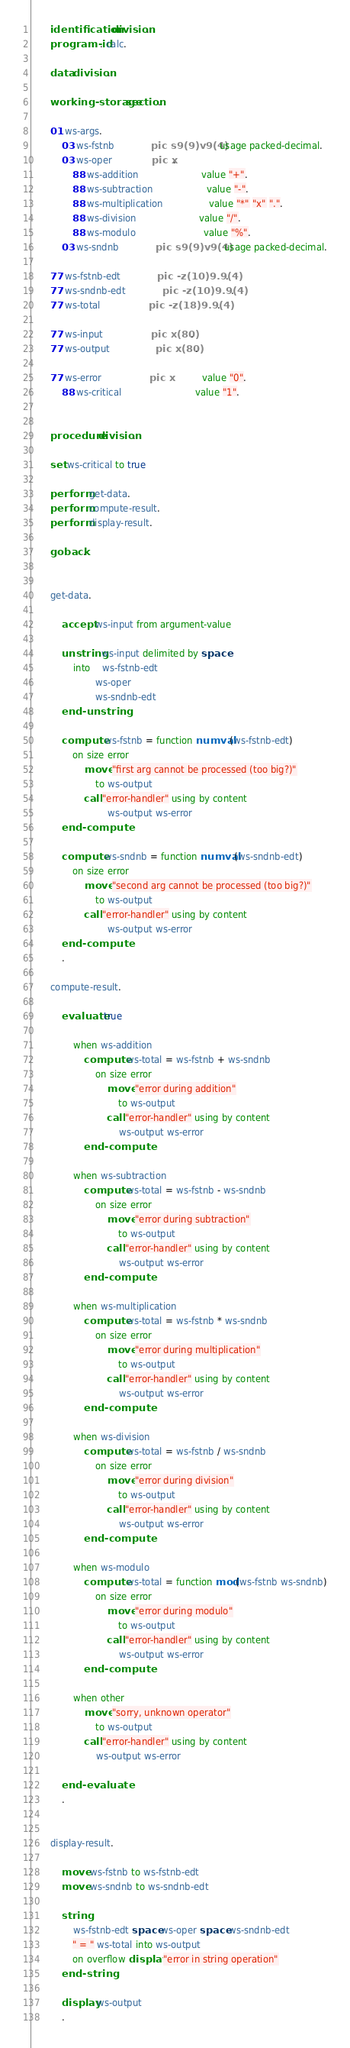Convert code to text. <code><loc_0><loc_0><loc_500><loc_500><_COBOL_>       identification division.
       program-id. calc.

       data division.

       working-storage section.

       01 ws-args.
           03 ws-fstnb             pic s9(9)v9(4)  usage packed-decimal.
           03 ws-oper              pic x.
               88 ws-addition                      value "+".
               88 ws-subtraction                   value "-".
               88 ws-multiplication                value "*" "x" ".".
               88 ws-division                      value "/".
               88 ws-modulo                        value "%".
           03 ws-sndnb             pic s9(9)v9(4)  usage packed-decimal.

       77 ws-fstnb-edt             pic -z(10)9.9(4).
       77 ws-sndnb-edt             pic -z(10)9.9(4).
       77 ws-total                 pic -z(18)9.9(4).

       77 ws-input                 pic x(80).
       77 ws-output                pic x(80).

       77 ws-error                 pic x           value "0".
           88 ws-critical                          value "1".


       procedure division.

       set ws-critical to true

       perform get-data.
       perform compute-result.
       perform display-result.

       goback.


       get-data.

           accept ws-input from argument-value

           unstring ws-input delimited by space
               into    ws-fstnb-edt
                       ws-oper
                       ws-sndnb-edt
           end-unstring

           compute ws-fstnb = function numval(ws-fstnb-edt)
               on size error
                   move "first arg cannot be processed (too big?)"
                       to ws-output
                   call "error-handler" using by content
                           ws-output ws-error
           end-compute

           compute ws-sndnb = function numval(ws-sndnb-edt)
               on size error
                   move "second arg cannot be processed (too big?)"
                       to ws-output
                   call "error-handler" using by content
                           ws-output ws-error
           end-compute
           .

       compute-result.

           evaluate true
       
               when ws-addition
                   compute ws-total = ws-fstnb + ws-sndnb
                       on size error
                           move "error during addition"
                               to ws-output
                           call "error-handler" using by content
                               ws-output ws-error
                   end-compute
       
               when ws-subtraction
                   compute ws-total = ws-fstnb - ws-sndnb
                       on size error
                           move "error during subtraction"
                               to ws-output
                           call "error-handler" using by content
                               ws-output ws-error
                   end-compute

               when ws-multiplication
                   compute ws-total = ws-fstnb * ws-sndnb
                       on size error
                           move "error during multiplication"
                               to ws-output
                           call "error-handler" using by content
                               ws-output ws-error
                   end-compute
       
               when ws-division
                   compute ws-total = ws-fstnb / ws-sndnb
                       on size error
                           move "error during division"
                               to ws-output
                           call "error-handler" using by content
                               ws-output ws-error
                   end-compute

               when ws-modulo
                   compute ws-total = function mod(ws-fstnb ws-sndnb)
                       on size error
                           move "error during modulo"
                               to ws-output
                           call "error-handler" using by content
                               ws-output ws-error
                   end-compute

               when other
                   move "sorry, unknown operator"
                       to ws-output
                   call "error-handler" using by content
                       ws-output ws-error

           end-evaluate
           .


       display-result.
           
           move ws-fstnb to ws-fstnb-edt
           move ws-sndnb to ws-sndnb-edt

           string
               ws-fstnb-edt space ws-oper space ws-sndnb-edt
               " = " ws-total into ws-output
               on overflow display "error in string operation"
           end-string

           display ws-output
           .
</code> 